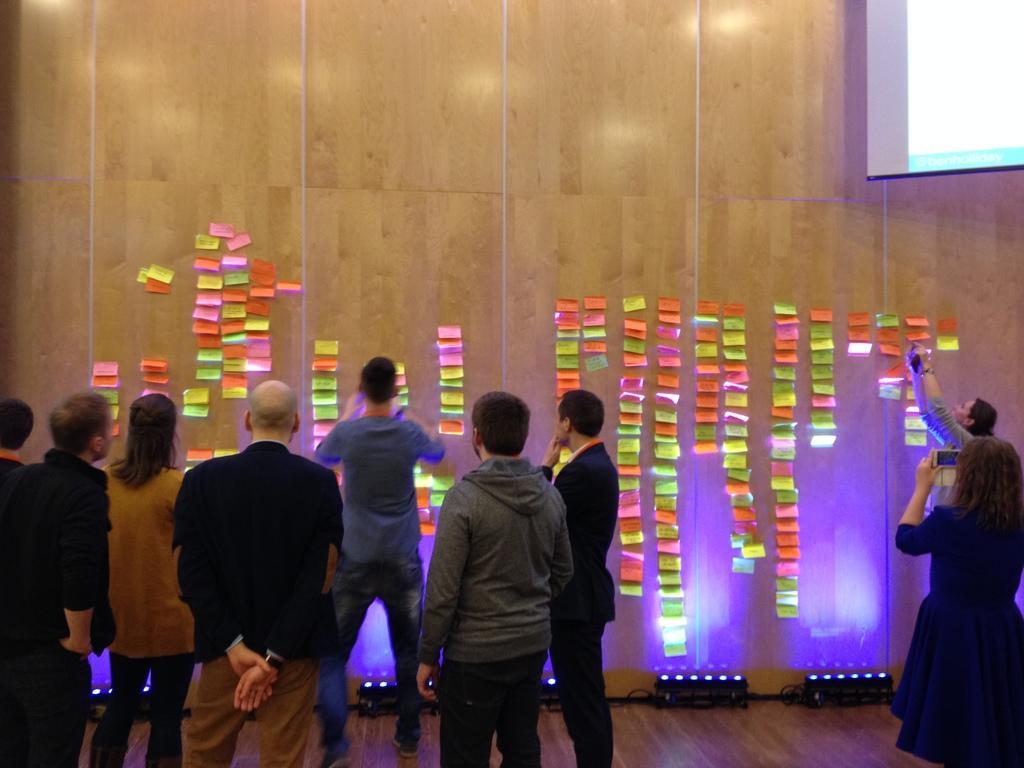Describe this image in one or two sentences. In this image I can see some people are standing. In the background, I can see something on the wall. 